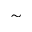Convert formula to latex. <formula><loc_0><loc_0><loc_500><loc_500>\sim</formula> 